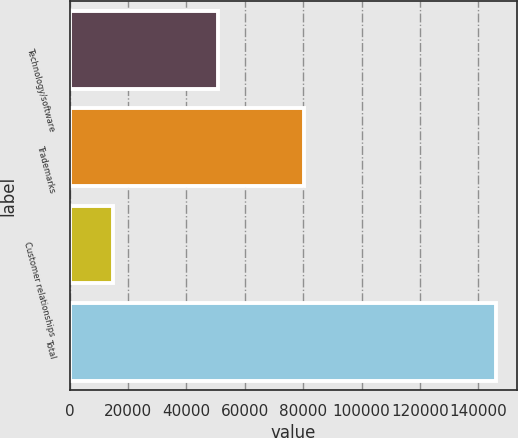<chart> <loc_0><loc_0><loc_500><loc_500><bar_chart><fcel>Technology/software<fcel>Trademarks<fcel>Customer relationships<fcel>Total<nl><fcel>50723<fcel>80336<fcel>14848<fcel>145907<nl></chart> 